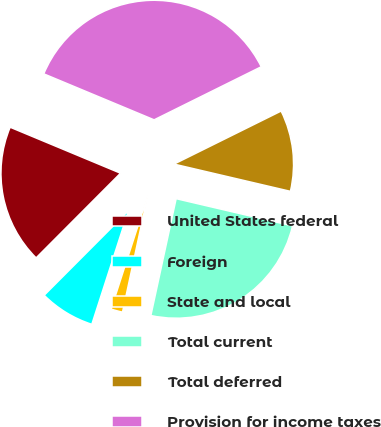Convert chart to OTSL. <chart><loc_0><loc_0><loc_500><loc_500><pie_chart><fcel>United States federal<fcel>Foreign<fcel>State and local<fcel>Total current<fcel>Total deferred<fcel>Provision for income taxes<nl><fcel>18.81%<fcel>7.5%<fcel>1.58%<fcel>24.73%<fcel>10.98%<fcel>36.39%<nl></chart> 